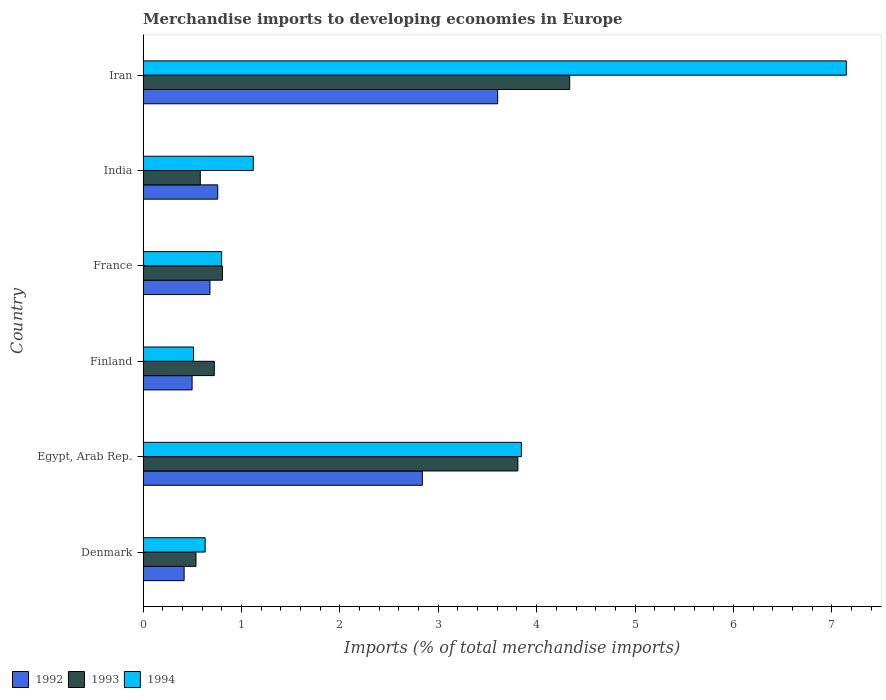How many different coloured bars are there?
Offer a terse response. 3. How many groups of bars are there?
Provide a succinct answer. 6. Are the number of bars per tick equal to the number of legend labels?
Make the answer very short. Yes. How many bars are there on the 3rd tick from the top?
Your answer should be compact. 3. In how many cases, is the number of bars for a given country not equal to the number of legend labels?
Make the answer very short. 0. What is the percentage total merchandise imports in 1994 in India?
Offer a very short reply. 1.12. Across all countries, what is the maximum percentage total merchandise imports in 1993?
Offer a terse response. 4.34. Across all countries, what is the minimum percentage total merchandise imports in 1993?
Your answer should be very brief. 0.54. In which country was the percentage total merchandise imports in 1993 maximum?
Your response must be concise. Iran. In which country was the percentage total merchandise imports in 1993 minimum?
Make the answer very short. Denmark. What is the total percentage total merchandise imports in 1993 in the graph?
Ensure brevity in your answer.  10.8. What is the difference between the percentage total merchandise imports in 1994 in Denmark and that in France?
Provide a succinct answer. -0.17. What is the difference between the percentage total merchandise imports in 1992 in France and the percentage total merchandise imports in 1994 in Finland?
Your answer should be very brief. 0.17. What is the average percentage total merchandise imports in 1994 per country?
Offer a terse response. 2.34. What is the difference between the percentage total merchandise imports in 1992 and percentage total merchandise imports in 1993 in India?
Offer a very short reply. 0.18. What is the ratio of the percentage total merchandise imports in 1992 in India to that in Iran?
Ensure brevity in your answer.  0.21. Is the difference between the percentage total merchandise imports in 1992 in Egypt, Arab Rep. and Finland greater than the difference between the percentage total merchandise imports in 1993 in Egypt, Arab Rep. and Finland?
Provide a short and direct response. No. What is the difference between the highest and the second highest percentage total merchandise imports in 1992?
Provide a succinct answer. 0.77. What is the difference between the highest and the lowest percentage total merchandise imports in 1992?
Provide a short and direct response. 3.19. Is it the case that in every country, the sum of the percentage total merchandise imports in 1993 and percentage total merchandise imports in 1994 is greater than the percentage total merchandise imports in 1992?
Your answer should be very brief. Yes. Are all the bars in the graph horizontal?
Make the answer very short. Yes. What is the difference between two consecutive major ticks on the X-axis?
Provide a succinct answer. 1. Are the values on the major ticks of X-axis written in scientific E-notation?
Your answer should be very brief. No. How many legend labels are there?
Offer a very short reply. 3. What is the title of the graph?
Offer a terse response. Merchandise imports to developing economies in Europe. What is the label or title of the X-axis?
Offer a very short reply. Imports (% of total merchandise imports). What is the Imports (% of total merchandise imports) of 1992 in Denmark?
Offer a terse response. 0.42. What is the Imports (% of total merchandise imports) of 1993 in Denmark?
Offer a terse response. 0.54. What is the Imports (% of total merchandise imports) in 1994 in Denmark?
Offer a terse response. 0.63. What is the Imports (% of total merchandise imports) in 1992 in Egypt, Arab Rep.?
Ensure brevity in your answer.  2.84. What is the Imports (% of total merchandise imports) of 1993 in Egypt, Arab Rep.?
Give a very brief answer. 3.81. What is the Imports (% of total merchandise imports) of 1994 in Egypt, Arab Rep.?
Give a very brief answer. 3.84. What is the Imports (% of total merchandise imports) of 1992 in Finland?
Provide a short and direct response. 0.5. What is the Imports (% of total merchandise imports) of 1993 in Finland?
Your answer should be compact. 0.72. What is the Imports (% of total merchandise imports) of 1994 in Finland?
Offer a terse response. 0.51. What is the Imports (% of total merchandise imports) in 1992 in France?
Your response must be concise. 0.68. What is the Imports (% of total merchandise imports) of 1993 in France?
Ensure brevity in your answer.  0.81. What is the Imports (% of total merchandise imports) in 1994 in France?
Give a very brief answer. 0.8. What is the Imports (% of total merchandise imports) in 1992 in India?
Your response must be concise. 0.76. What is the Imports (% of total merchandise imports) of 1993 in India?
Ensure brevity in your answer.  0.58. What is the Imports (% of total merchandise imports) of 1994 in India?
Keep it short and to the point. 1.12. What is the Imports (% of total merchandise imports) of 1992 in Iran?
Offer a terse response. 3.6. What is the Imports (% of total merchandise imports) of 1993 in Iran?
Keep it short and to the point. 4.34. What is the Imports (% of total merchandise imports) in 1994 in Iran?
Give a very brief answer. 7.15. Across all countries, what is the maximum Imports (% of total merchandise imports) in 1992?
Your answer should be very brief. 3.6. Across all countries, what is the maximum Imports (% of total merchandise imports) of 1993?
Make the answer very short. 4.34. Across all countries, what is the maximum Imports (% of total merchandise imports) of 1994?
Keep it short and to the point. 7.15. Across all countries, what is the minimum Imports (% of total merchandise imports) in 1992?
Provide a short and direct response. 0.42. Across all countries, what is the minimum Imports (% of total merchandise imports) in 1993?
Provide a succinct answer. 0.54. Across all countries, what is the minimum Imports (% of total merchandise imports) in 1994?
Offer a terse response. 0.51. What is the total Imports (% of total merchandise imports) of 1992 in the graph?
Your answer should be very brief. 8.8. What is the total Imports (% of total merchandise imports) in 1993 in the graph?
Your answer should be very brief. 10.8. What is the total Imports (% of total merchandise imports) in 1994 in the graph?
Your response must be concise. 14.05. What is the difference between the Imports (% of total merchandise imports) of 1992 in Denmark and that in Egypt, Arab Rep.?
Provide a succinct answer. -2.42. What is the difference between the Imports (% of total merchandise imports) in 1993 in Denmark and that in Egypt, Arab Rep.?
Keep it short and to the point. -3.27. What is the difference between the Imports (% of total merchandise imports) of 1994 in Denmark and that in Egypt, Arab Rep.?
Ensure brevity in your answer.  -3.21. What is the difference between the Imports (% of total merchandise imports) of 1992 in Denmark and that in Finland?
Your response must be concise. -0.08. What is the difference between the Imports (% of total merchandise imports) of 1993 in Denmark and that in Finland?
Your response must be concise. -0.19. What is the difference between the Imports (% of total merchandise imports) of 1994 in Denmark and that in Finland?
Ensure brevity in your answer.  0.12. What is the difference between the Imports (% of total merchandise imports) in 1992 in Denmark and that in France?
Provide a short and direct response. -0.26. What is the difference between the Imports (% of total merchandise imports) of 1993 in Denmark and that in France?
Make the answer very short. -0.27. What is the difference between the Imports (% of total merchandise imports) of 1994 in Denmark and that in France?
Offer a terse response. -0.17. What is the difference between the Imports (% of total merchandise imports) in 1992 in Denmark and that in India?
Keep it short and to the point. -0.34. What is the difference between the Imports (% of total merchandise imports) in 1993 in Denmark and that in India?
Give a very brief answer. -0.04. What is the difference between the Imports (% of total merchandise imports) of 1994 in Denmark and that in India?
Your response must be concise. -0.49. What is the difference between the Imports (% of total merchandise imports) in 1992 in Denmark and that in Iran?
Offer a very short reply. -3.19. What is the difference between the Imports (% of total merchandise imports) in 1993 in Denmark and that in Iran?
Your response must be concise. -3.8. What is the difference between the Imports (% of total merchandise imports) in 1994 in Denmark and that in Iran?
Offer a very short reply. -6.52. What is the difference between the Imports (% of total merchandise imports) in 1992 in Egypt, Arab Rep. and that in Finland?
Offer a very short reply. 2.34. What is the difference between the Imports (% of total merchandise imports) of 1993 in Egypt, Arab Rep. and that in Finland?
Offer a terse response. 3.09. What is the difference between the Imports (% of total merchandise imports) of 1994 in Egypt, Arab Rep. and that in Finland?
Give a very brief answer. 3.33. What is the difference between the Imports (% of total merchandise imports) in 1992 in Egypt, Arab Rep. and that in France?
Ensure brevity in your answer.  2.16. What is the difference between the Imports (% of total merchandise imports) of 1993 in Egypt, Arab Rep. and that in France?
Your answer should be compact. 3. What is the difference between the Imports (% of total merchandise imports) in 1994 in Egypt, Arab Rep. and that in France?
Provide a short and direct response. 3.05. What is the difference between the Imports (% of total merchandise imports) of 1992 in Egypt, Arab Rep. and that in India?
Your answer should be compact. 2.08. What is the difference between the Imports (% of total merchandise imports) in 1993 in Egypt, Arab Rep. and that in India?
Ensure brevity in your answer.  3.23. What is the difference between the Imports (% of total merchandise imports) in 1994 in Egypt, Arab Rep. and that in India?
Your answer should be compact. 2.72. What is the difference between the Imports (% of total merchandise imports) of 1992 in Egypt, Arab Rep. and that in Iran?
Give a very brief answer. -0.77. What is the difference between the Imports (% of total merchandise imports) in 1993 in Egypt, Arab Rep. and that in Iran?
Your answer should be compact. -0.53. What is the difference between the Imports (% of total merchandise imports) of 1994 in Egypt, Arab Rep. and that in Iran?
Offer a very short reply. -3.3. What is the difference between the Imports (% of total merchandise imports) in 1992 in Finland and that in France?
Provide a succinct answer. -0.18. What is the difference between the Imports (% of total merchandise imports) of 1993 in Finland and that in France?
Keep it short and to the point. -0.08. What is the difference between the Imports (% of total merchandise imports) of 1994 in Finland and that in France?
Your answer should be compact. -0.29. What is the difference between the Imports (% of total merchandise imports) of 1992 in Finland and that in India?
Provide a short and direct response. -0.26. What is the difference between the Imports (% of total merchandise imports) in 1993 in Finland and that in India?
Your answer should be very brief. 0.14. What is the difference between the Imports (% of total merchandise imports) in 1994 in Finland and that in India?
Keep it short and to the point. -0.61. What is the difference between the Imports (% of total merchandise imports) in 1992 in Finland and that in Iran?
Keep it short and to the point. -3.11. What is the difference between the Imports (% of total merchandise imports) of 1993 in Finland and that in Iran?
Provide a short and direct response. -3.61. What is the difference between the Imports (% of total merchandise imports) of 1994 in Finland and that in Iran?
Make the answer very short. -6.63. What is the difference between the Imports (% of total merchandise imports) in 1992 in France and that in India?
Provide a short and direct response. -0.08. What is the difference between the Imports (% of total merchandise imports) in 1993 in France and that in India?
Ensure brevity in your answer.  0.22. What is the difference between the Imports (% of total merchandise imports) in 1994 in France and that in India?
Your answer should be compact. -0.32. What is the difference between the Imports (% of total merchandise imports) in 1992 in France and that in Iran?
Make the answer very short. -2.92. What is the difference between the Imports (% of total merchandise imports) in 1993 in France and that in Iran?
Offer a terse response. -3.53. What is the difference between the Imports (% of total merchandise imports) of 1994 in France and that in Iran?
Your answer should be compact. -6.35. What is the difference between the Imports (% of total merchandise imports) of 1992 in India and that in Iran?
Offer a very short reply. -2.84. What is the difference between the Imports (% of total merchandise imports) in 1993 in India and that in Iran?
Make the answer very short. -3.75. What is the difference between the Imports (% of total merchandise imports) in 1994 in India and that in Iran?
Keep it short and to the point. -6.03. What is the difference between the Imports (% of total merchandise imports) of 1992 in Denmark and the Imports (% of total merchandise imports) of 1993 in Egypt, Arab Rep.?
Provide a succinct answer. -3.39. What is the difference between the Imports (% of total merchandise imports) of 1992 in Denmark and the Imports (% of total merchandise imports) of 1994 in Egypt, Arab Rep.?
Provide a short and direct response. -3.43. What is the difference between the Imports (% of total merchandise imports) in 1993 in Denmark and the Imports (% of total merchandise imports) in 1994 in Egypt, Arab Rep.?
Your answer should be very brief. -3.31. What is the difference between the Imports (% of total merchandise imports) in 1992 in Denmark and the Imports (% of total merchandise imports) in 1993 in Finland?
Provide a short and direct response. -0.31. What is the difference between the Imports (% of total merchandise imports) of 1992 in Denmark and the Imports (% of total merchandise imports) of 1994 in Finland?
Offer a very short reply. -0.1. What is the difference between the Imports (% of total merchandise imports) in 1993 in Denmark and the Imports (% of total merchandise imports) in 1994 in Finland?
Ensure brevity in your answer.  0.03. What is the difference between the Imports (% of total merchandise imports) of 1992 in Denmark and the Imports (% of total merchandise imports) of 1993 in France?
Provide a short and direct response. -0.39. What is the difference between the Imports (% of total merchandise imports) in 1992 in Denmark and the Imports (% of total merchandise imports) in 1994 in France?
Your response must be concise. -0.38. What is the difference between the Imports (% of total merchandise imports) of 1993 in Denmark and the Imports (% of total merchandise imports) of 1994 in France?
Give a very brief answer. -0.26. What is the difference between the Imports (% of total merchandise imports) of 1992 in Denmark and the Imports (% of total merchandise imports) of 1993 in India?
Ensure brevity in your answer.  -0.16. What is the difference between the Imports (% of total merchandise imports) in 1992 in Denmark and the Imports (% of total merchandise imports) in 1994 in India?
Offer a very short reply. -0.7. What is the difference between the Imports (% of total merchandise imports) of 1993 in Denmark and the Imports (% of total merchandise imports) of 1994 in India?
Provide a short and direct response. -0.58. What is the difference between the Imports (% of total merchandise imports) of 1992 in Denmark and the Imports (% of total merchandise imports) of 1993 in Iran?
Offer a very short reply. -3.92. What is the difference between the Imports (% of total merchandise imports) of 1992 in Denmark and the Imports (% of total merchandise imports) of 1994 in Iran?
Provide a short and direct response. -6.73. What is the difference between the Imports (% of total merchandise imports) of 1993 in Denmark and the Imports (% of total merchandise imports) of 1994 in Iran?
Your answer should be compact. -6.61. What is the difference between the Imports (% of total merchandise imports) in 1992 in Egypt, Arab Rep. and the Imports (% of total merchandise imports) in 1993 in Finland?
Make the answer very short. 2.11. What is the difference between the Imports (% of total merchandise imports) in 1992 in Egypt, Arab Rep. and the Imports (% of total merchandise imports) in 1994 in Finland?
Make the answer very short. 2.33. What is the difference between the Imports (% of total merchandise imports) in 1993 in Egypt, Arab Rep. and the Imports (% of total merchandise imports) in 1994 in Finland?
Your answer should be very brief. 3.3. What is the difference between the Imports (% of total merchandise imports) in 1992 in Egypt, Arab Rep. and the Imports (% of total merchandise imports) in 1993 in France?
Your answer should be very brief. 2.03. What is the difference between the Imports (% of total merchandise imports) in 1992 in Egypt, Arab Rep. and the Imports (% of total merchandise imports) in 1994 in France?
Give a very brief answer. 2.04. What is the difference between the Imports (% of total merchandise imports) in 1993 in Egypt, Arab Rep. and the Imports (% of total merchandise imports) in 1994 in France?
Provide a succinct answer. 3.01. What is the difference between the Imports (% of total merchandise imports) in 1992 in Egypt, Arab Rep. and the Imports (% of total merchandise imports) in 1993 in India?
Offer a very short reply. 2.26. What is the difference between the Imports (% of total merchandise imports) of 1992 in Egypt, Arab Rep. and the Imports (% of total merchandise imports) of 1994 in India?
Provide a short and direct response. 1.72. What is the difference between the Imports (% of total merchandise imports) in 1993 in Egypt, Arab Rep. and the Imports (% of total merchandise imports) in 1994 in India?
Ensure brevity in your answer.  2.69. What is the difference between the Imports (% of total merchandise imports) in 1992 in Egypt, Arab Rep. and the Imports (% of total merchandise imports) in 1993 in Iran?
Your answer should be very brief. -1.5. What is the difference between the Imports (% of total merchandise imports) of 1992 in Egypt, Arab Rep. and the Imports (% of total merchandise imports) of 1994 in Iran?
Your answer should be very brief. -4.31. What is the difference between the Imports (% of total merchandise imports) in 1993 in Egypt, Arab Rep. and the Imports (% of total merchandise imports) in 1994 in Iran?
Make the answer very short. -3.34. What is the difference between the Imports (% of total merchandise imports) in 1992 in Finland and the Imports (% of total merchandise imports) in 1993 in France?
Give a very brief answer. -0.31. What is the difference between the Imports (% of total merchandise imports) in 1992 in Finland and the Imports (% of total merchandise imports) in 1994 in France?
Ensure brevity in your answer.  -0.3. What is the difference between the Imports (% of total merchandise imports) of 1993 in Finland and the Imports (% of total merchandise imports) of 1994 in France?
Provide a succinct answer. -0.07. What is the difference between the Imports (% of total merchandise imports) of 1992 in Finland and the Imports (% of total merchandise imports) of 1993 in India?
Make the answer very short. -0.08. What is the difference between the Imports (% of total merchandise imports) in 1992 in Finland and the Imports (% of total merchandise imports) in 1994 in India?
Offer a very short reply. -0.62. What is the difference between the Imports (% of total merchandise imports) in 1993 in Finland and the Imports (% of total merchandise imports) in 1994 in India?
Keep it short and to the point. -0.4. What is the difference between the Imports (% of total merchandise imports) in 1992 in Finland and the Imports (% of total merchandise imports) in 1993 in Iran?
Ensure brevity in your answer.  -3.84. What is the difference between the Imports (% of total merchandise imports) in 1992 in Finland and the Imports (% of total merchandise imports) in 1994 in Iran?
Your answer should be compact. -6.65. What is the difference between the Imports (% of total merchandise imports) of 1993 in Finland and the Imports (% of total merchandise imports) of 1994 in Iran?
Keep it short and to the point. -6.42. What is the difference between the Imports (% of total merchandise imports) in 1992 in France and the Imports (% of total merchandise imports) in 1993 in India?
Keep it short and to the point. 0.1. What is the difference between the Imports (% of total merchandise imports) of 1992 in France and the Imports (% of total merchandise imports) of 1994 in India?
Ensure brevity in your answer.  -0.44. What is the difference between the Imports (% of total merchandise imports) of 1993 in France and the Imports (% of total merchandise imports) of 1994 in India?
Your answer should be very brief. -0.31. What is the difference between the Imports (% of total merchandise imports) of 1992 in France and the Imports (% of total merchandise imports) of 1993 in Iran?
Keep it short and to the point. -3.66. What is the difference between the Imports (% of total merchandise imports) in 1992 in France and the Imports (% of total merchandise imports) in 1994 in Iran?
Give a very brief answer. -6.47. What is the difference between the Imports (% of total merchandise imports) in 1993 in France and the Imports (% of total merchandise imports) in 1994 in Iran?
Give a very brief answer. -6.34. What is the difference between the Imports (% of total merchandise imports) in 1992 in India and the Imports (% of total merchandise imports) in 1993 in Iran?
Your answer should be very brief. -3.58. What is the difference between the Imports (% of total merchandise imports) of 1992 in India and the Imports (% of total merchandise imports) of 1994 in Iran?
Your response must be concise. -6.39. What is the difference between the Imports (% of total merchandise imports) in 1993 in India and the Imports (% of total merchandise imports) in 1994 in Iran?
Your answer should be compact. -6.57. What is the average Imports (% of total merchandise imports) in 1992 per country?
Your answer should be compact. 1.47. What is the average Imports (% of total merchandise imports) of 1993 per country?
Your answer should be compact. 1.8. What is the average Imports (% of total merchandise imports) of 1994 per country?
Your response must be concise. 2.34. What is the difference between the Imports (% of total merchandise imports) in 1992 and Imports (% of total merchandise imports) in 1993 in Denmark?
Make the answer very short. -0.12. What is the difference between the Imports (% of total merchandise imports) in 1992 and Imports (% of total merchandise imports) in 1994 in Denmark?
Provide a succinct answer. -0.21. What is the difference between the Imports (% of total merchandise imports) of 1993 and Imports (% of total merchandise imports) of 1994 in Denmark?
Provide a succinct answer. -0.09. What is the difference between the Imports (% of total merchandise imports) in 1992 and Imports (% of total merchandise imports) in 1993 in Egypt, Arab Rep.?
Offer a very short reply. -0.97. What is the difference between the Imports (% of total merchandise imports) in 1992 and Imports (% of total merchandise imports) in 1994 in Egypt, Arab Rep.?
Make the answer very short. -1.01. What is the difference between the Imports (% of total merchandise imports) of 1993 and Imports (% of total merchandise imports) of 1994 in Egypt, Arab Rep.?
Ensure brevity in your answer.  -0.04. What is the difference between the Imports (% of total merchandise imports) in 1992 and Imports (% of total merchandise imports) in 1993 in Finland?
Keep it short and to the point. -0.23. What is the difference between the Imports (% of total merchandise imports) in 1992 and Imports (% of total merchandise imports) in 1994 in Finland?
Offer a very short reply. -0.01. What is the difference between the Imports (% of total merchandise imports) in 1993 and Imports (% of total merchandise imports) in 1994 in Finland?
Offer a terse response. 0.21. What is the difference between the Imports (% of total merchandise imports) of 1992 and Imports (% of total merchandise imports) of 1993 in France?
Give a very brief answer. -0.13. What is the difference between the Imports (% of total merchandise imports) of 1992 and Imports (% of total merchandise imports) of 1994 in France?
Your response must be concise. -0.12. What is the difference between the Imports (% of total merchandise imports) of 1993 and Imports (% of total merchandise imports) of 1994 in France?
Offer a very short reply. 0.01. What is the difference between the Imports (% of total merchandise imports) of 1992 and Imports (% of total merchandise imports) of 1993 in India?
Give a very brief answer. 0.18. What is the difference between the Imports (% of total merchandise imports) in 1992 and Imports (% of total merchandise imports) in 1994 in India?
Your response must be concise. -0.36. What is the difference between the Imports (% of total merchandise imports) in 1993 and Imports (% of total merchandise imports) in 1994 in India?
Keep it short and to the point. -0.54. What is the difference between the Imports (% of total merchandise imports) of 1992 and Imports (% of total merchandise imports) of 1993 in Iran?
Provide a short and direct response. -0.73. What is the difference between the Imports (% of total merchandise imports) in 1992 and Imports (% of total merchandise imports) in 1994 in Iran?
Your answer should be compact. -3.54. What is the difference between the Imports (% of total merchandise imports) in 1993 and Imports (% of total merchandise imports) in 1994 in Iran?
Your answer should be compact. -2.81. What is the ratio of the Imports (% of total merchandise imports) in 1992 in Denmark to that in Egypt, Arab Rep.?
Provide a succinct answer. 0.15. What is the ratio of the Imports (% of total merchandise imports) of 1993 in Denmark to that in Egypt, Arab Rep.?
Your answer should be very brief. 0.14. What is the ratio of the Imports (% of total merchandise imports) in 1994 in Denmark to that in Egypt, Arab Rep.?
Make the answer very short. 0.16. What is the ratio of the Imports (% of total merchandise imports) of 1992 in Denmark to that in Finland?
Provide a short and direct response. 0.84. What is the ratio of the Imports (% of total merchandise imports) of 1993 in Denmark to that in Finland?
Your response must be concise. 0.74. What is the ratio of the Imports (% of total merchandise imports) in 1994 in Denmark to that in Finland?
Make the answer very short. 1.23. What is the ratio of the Imports (% of total merchandise imports) of 1992 in Denmark to that in France?
Provide a succinct answer. 0.61. What is the ratio of the Imports (% of total merchandise imports) in 1993 in Denmark to that in France?
Keep it short and to the point. 0.67. What is the ratio of the Imports (% of total merchandise imports) in 1994 in Denmark to that in France?
Provide a short and direct response. 0.79. What is the ratio of the Imports (% of total merchandise imports) of 1992 in Denmark to that in India?
Your answer should be compact. 0.55. What is the ratio of the Imports (% of total merchandise imports) of 1993 in Denmark to that in India?
Ensure brevity in your answer.  0.93. What is the ratio of the Imports (% of total merchandise imports) in 1994 in Denmark to that in India?
Provide a succinct answer. 0.56. What is the ratio of the Imports (% of total merchandise imports) in 1992 in Denmark to that in Iran?
Keep it short and to the point. 0.12. What is the ratio of the Imports (% of total merchandise imports) of 1993 in Denmark to that in Iran?
Offer a terse response. 0.12. What is the ratio of the Imports (% of total merchandise imports) in 1994 in Denmark to that in Iran?
Offer a very short reply. 0.09. What is the ratio of the Imports (% of total merchandise imports) of 1992 in Egypt, Arab Rep. to that in Finland?
Your response must be concise. 5.69. What is the ratio of the Imports (% of total merchandise imports) in 1993 in Egypt, Arab Rep. to that in Finland?
Ensure brevity in your answer.  5.26. What is the ratio of the Imports (% of total merchandise imports) of 1994 in Egypt, Arab Rep. to that in Finland?
Offer a very short reply. 7.5. What is the ratio of the Imports (% of total merchandise imports) of 1992 in Egypt, Arab Rep. to that in France?
Give a very brief answer. 4.17. What is the ratio of the Imports (% of total merchandise imports) in 1993 in Egypt, Arab Rep. to that in France?
Provide a short and direct response. 4.72. What is the ratio of the Imports (% of total merchandise imports) in 1994 in Egypt, Arab Rep. to that in France?
Offer a terse response. 4.82. What is the ratio of the Imports (% of total merchandise imports) of 1992 in Egypt, Arab Rep. to that in India?
Your response must be concise. 3.74. What is the ratio of the Imports (% of total merchandise imports) of 1993 in Egypt, Arab Rep. to that in India?
Keep it short and to the point. 6.55. What is the ratio of the Imports (% of total merchandise imports) of 1994 in Egypt, Arab Rep. to that in India?
Make the answer very short. 3.43. What is the ratio of the Imports (% of total merchandise imports) in 1992 in Egypt, Arab Rep. to that in Iran?
Keep it short and to the point. 0.79. What is the ratio of the Imports (% of total merchandise imports) in 1993 in Egypt, Arab Rep. to that in Iran?
Your answer should be compact. 0.88. What is the ratio of the Imports (% of total merchandise imports) in 1994 in Egypt, Arab Rep. to that in Iran?
Your response must be concise. 0.54. What is the ratio of the Imports (% of total merchandise imports) in 1992 in Finland to that in France?
Provide a short and direct response. 0.73. What is the ratio of the Imports (% of total merchandise imports) in 1993 in Finland to that in France?
Provide a short and direct response. 0.9. What is the ratio of the Imports (% of total merchandise imports) of 1994 in Finland to that in France?
Make the answer very short. 0.64. What is the ratio of the Imports (% of total merchandise imports) in 1992 in Finland to that in India?
Keep it short and to the point. 0.66. What is the ratio of the Imports (% of total merchandise imports) in 1993 in Finland to that in India?
Your answer should be compact. 1.24. What is the ratio of the Imports (% of total merchandise imports) in 1994 in Finland to that in India?
Offer a very short reply. 0.46. What is the ratio of the Imports (% of total merchandise imports) in 1992 in Finland to that in Iran?
Your answer should be compact. 0.14. What is the ratio of the Imports (% of total merchandise imports) in 1993 in Finland to that in Iran?
Keep it short and to the point. 0.17. What is the ratio of the Imports (% of total merchandise imports) in 1994 in Finland to that in Iran?
Give a very brief answer. 0.07. What is the ratio of the Imports (% of total merchandise imports) of 1992 in France to that in India?
Keep it short and to the point. 0.9. What is the ratio of the Imports (% of total merchandise imports) of 1993 in France to that in India?
Offer a very short reply. 1.39. What is the ratio of the Imports (% of total merchandise imports) in 1994 in France to that in India?
Make the answer very short. 0.71. What is the ratio of the Imports (% of total merchandise imports) in 1992 in France to that in Iran?
Offer a terse response. 0.19. What is the ratio of the Imports (% of total merchandise imports) in 1993 in France to that in Iran?
Offer a terse response. 0.19. What is the ratio of the Imports (% of total merchandise imports) of 1994 in France to that in Iran?
Your answer should be compact. 0.11. What is the ratio of the Imports (% of total merchandise imports) in 1992 in India to that in Iran?
Offer a very short reply. 0.21. What is the ratio of the Imports (% of total merchandise imports) of 1993 in India to that in Iran?
Offer a terse response. 0.13. What is the ratio of the Imports (% of total merchandise imports) of 1994 in India to that in Iran?
Your answer should be very brief. 0.16. What is the difference between the highest and the second highest Imports (% of total merchandise imports) of 1992?
Give a very brief answer. 0.77. What is the difference between the highest and the second highest Imports (% of total merchandise imports) of 1993?
Your answer should be compact. 0.53. What is the difference between the highest and the second highest Imports (% of total merchandise imports) of 1994?
Your answer should be very brief. 3.3. What is the difference between the highest and the lowest Imports (% of total merchandise imports) of 1992?
Provide a short and direct response. 3.19. What is the difference between the highest and the lowest Imports (% of total merchandise imports) of 1993?
Give a very brief answer. 3.8. What is the difference between the highest and the lowest Imports (% of total merchandise imports) in 1994?
Provide a succinct answer. 6.63. 